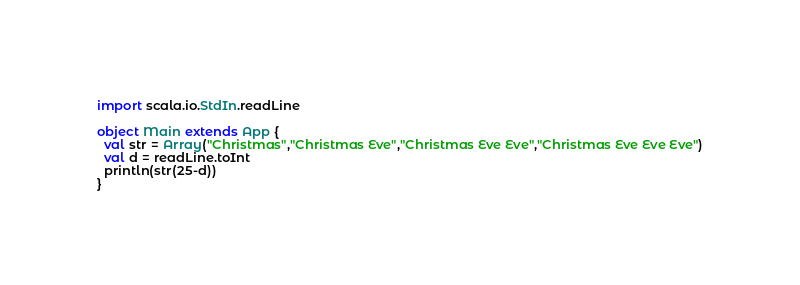<code> <loc_0><loc_0><loc_500><loc_500><_Scala_>import scala.io.StdIn.readLine

object Main extends App {
  val str = Array("Christmas","Christmas Eve","Christmas Eve Eve","Christmas Eve Eve Eve")
  val d = readLine.toInt
  println(str(25-d))
}</code> 